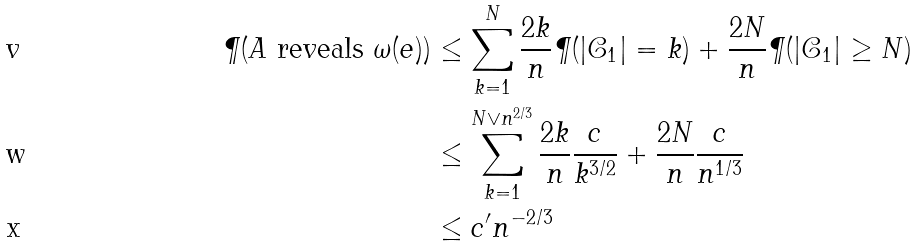Convert formula to latex. <formula><loc_0><loc_0><loc_500><loc_500>\P ( A \text { reveals } \omega ( e ) ) & \leq \sum _ { k = 1 } ^ { N } \frac { 2 k } { n } \P ( | \mathcal { C } _ { 1 } | = k ) + \frac { 2 N } { n } \P ( | \mathcal { C } _ { 1 } | \geq N ) \\ & \leq \sum _ { k = 1 } ^ { N \vee n ^ { 2 / 3 } } \frac { 2 k } { n } \frac { c } { k ^ { 3 / 2 } } + \frac { 2 N } { n } \frac { c } { n ^ { 1 / 3 } } \\ & \leq c ^ { \prime } n ^ { - 2 / 3 }</formula> 